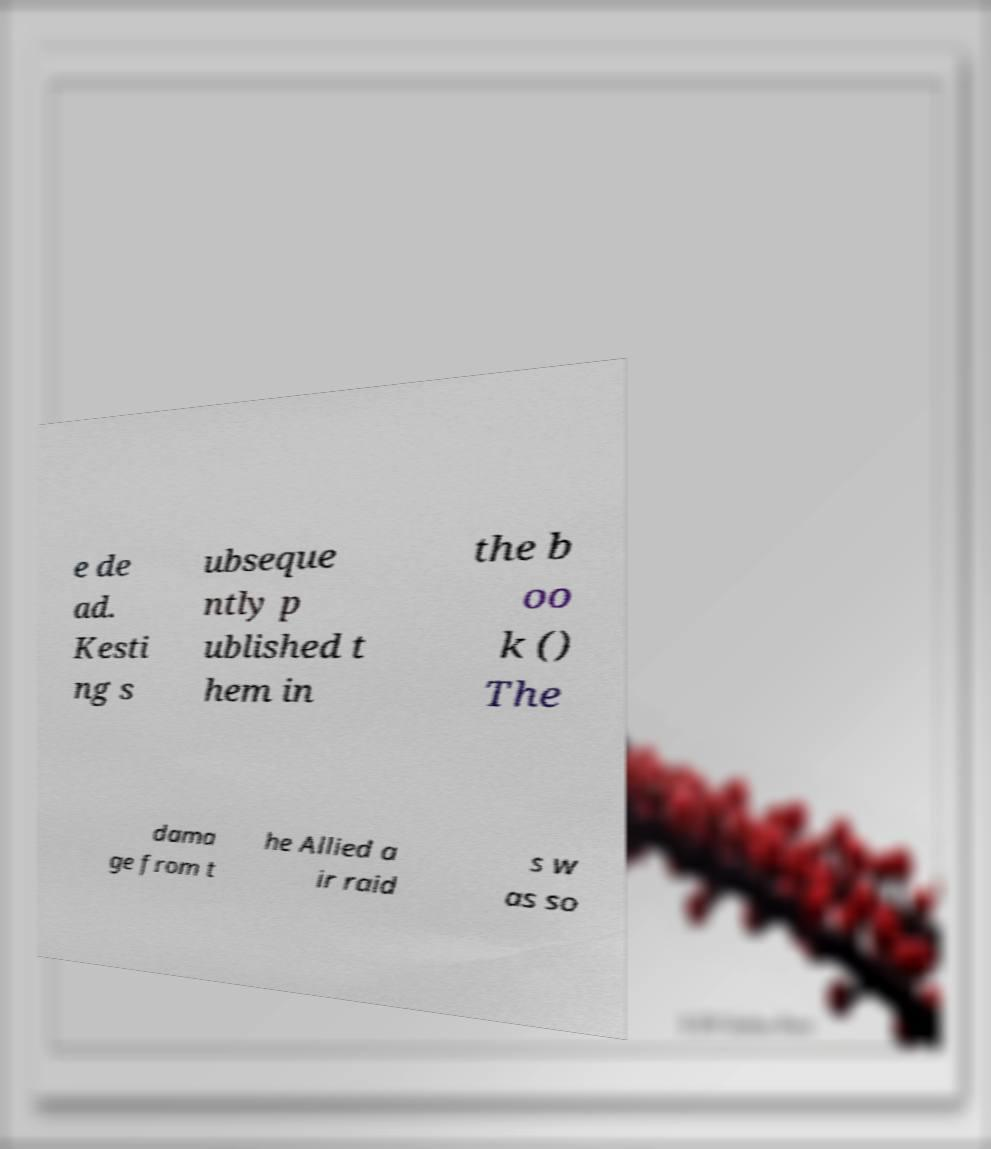Can you accurately transcribe the text from the provided image for me? e de ad. Kesti ng s ubseque ntly p ublished t hem in the b oo k () The dama ge from t he Allied a ir raid s w as so 